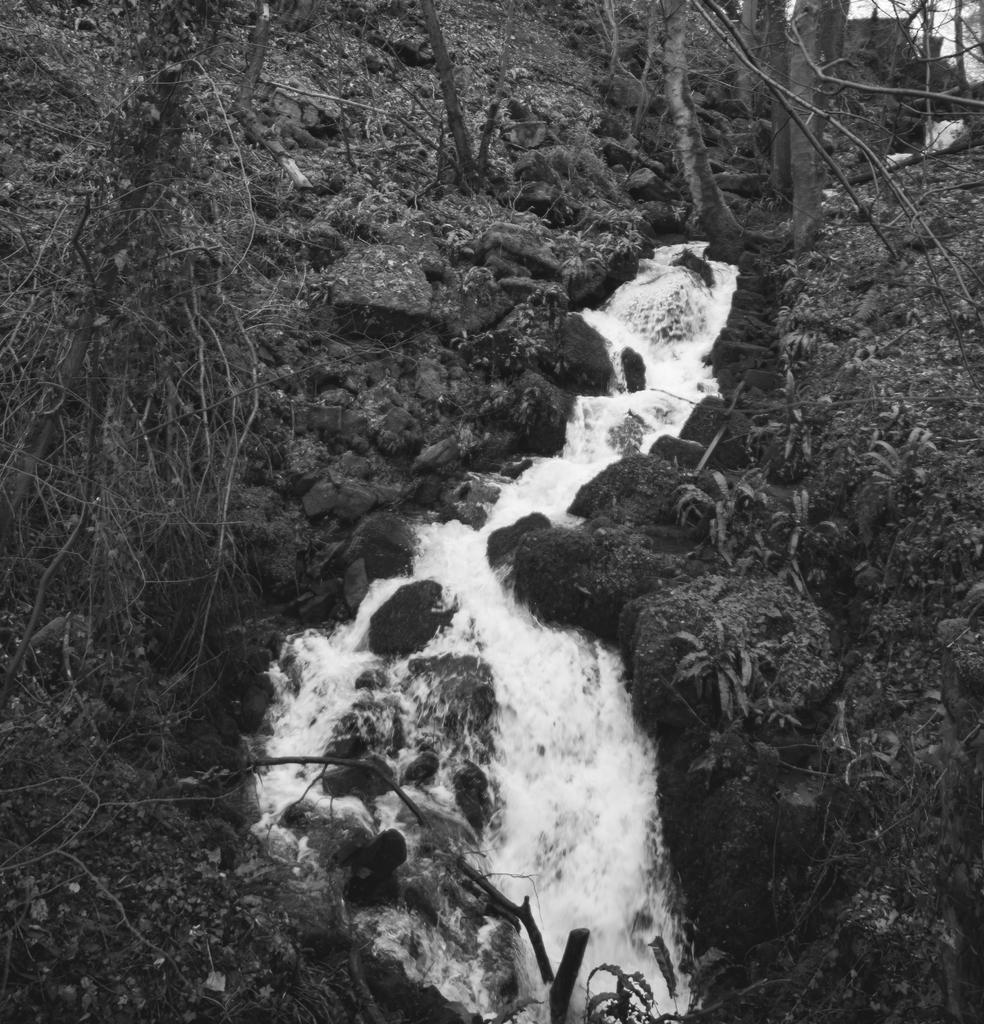What is the main feature in the center of the image? There is a waterfall in the center of the image. What can be seen in the background of the image? There are trees in the background of the image. What type of rice is being harvested along the trail in the image? There is no rice or trail present in the image; it features a waterfall and trees in the background. 